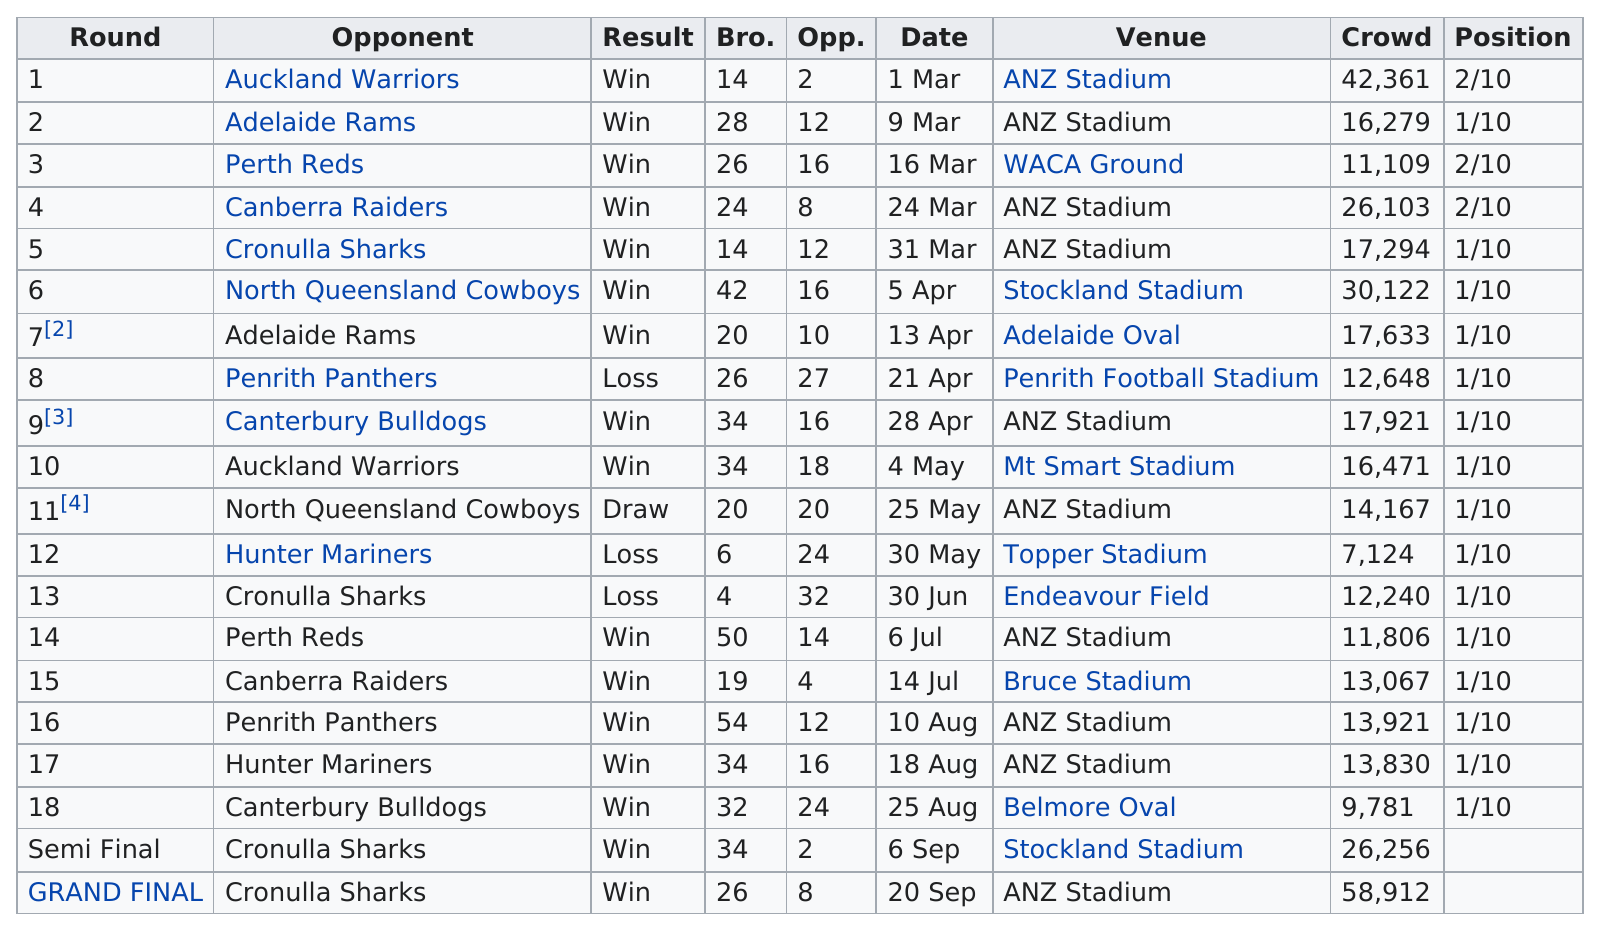Indicate a few pertinent items in this graphic. At least 16 wins did they have. The crowd was above 20,000 people in 5 games. In total, 20 games were played. The Denver Broncos played against a total of 9 different teams this season. Nine opponents have been faced by the person in question. 